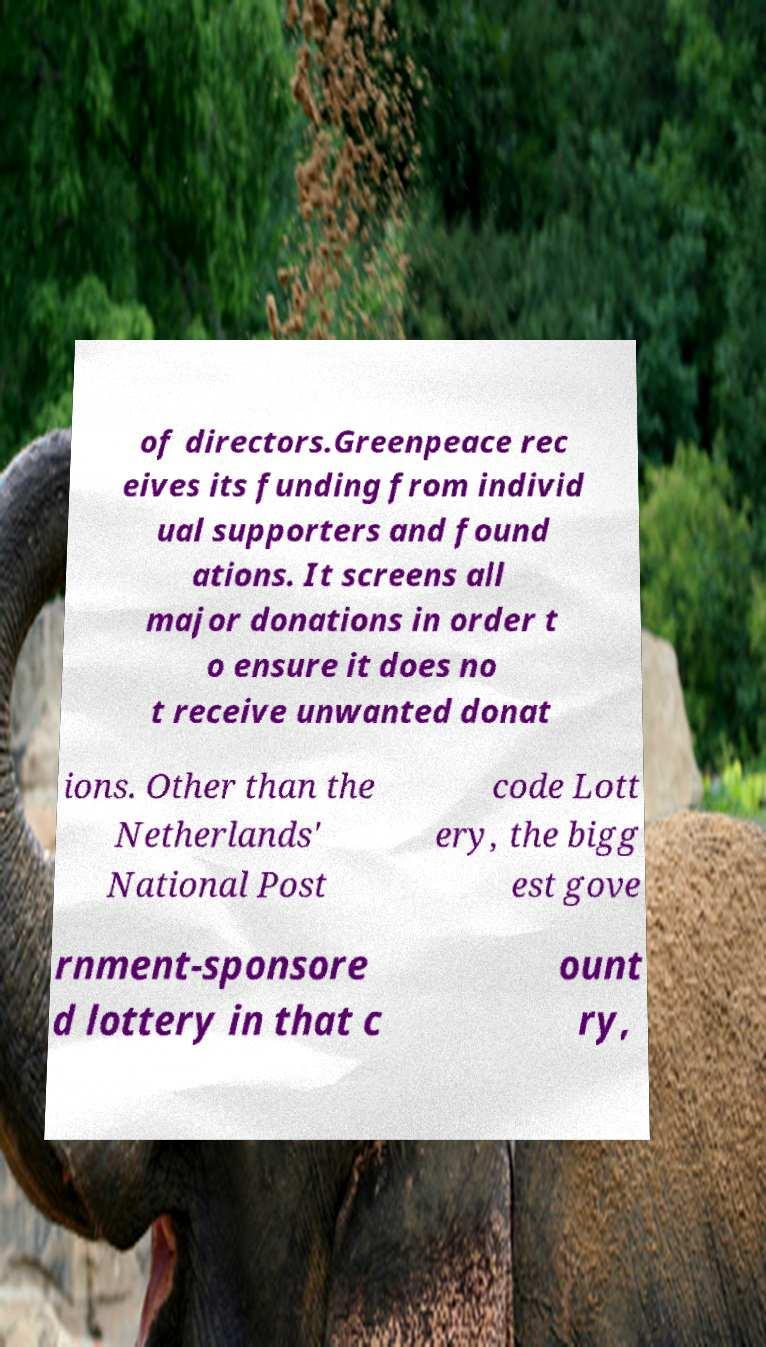Could you assist in decoding the text presented in this image and type it out clearly? of directors.Greenpeace rec eives its funding from individ ual supporters and found ations. It screens all major donations in order t o ensure it does no t receive unwanted donat ions. Other than the Netherlands' National Post code Lott ery, the bigg est gove rnment-sponsore d lottery in that c ount ry, 